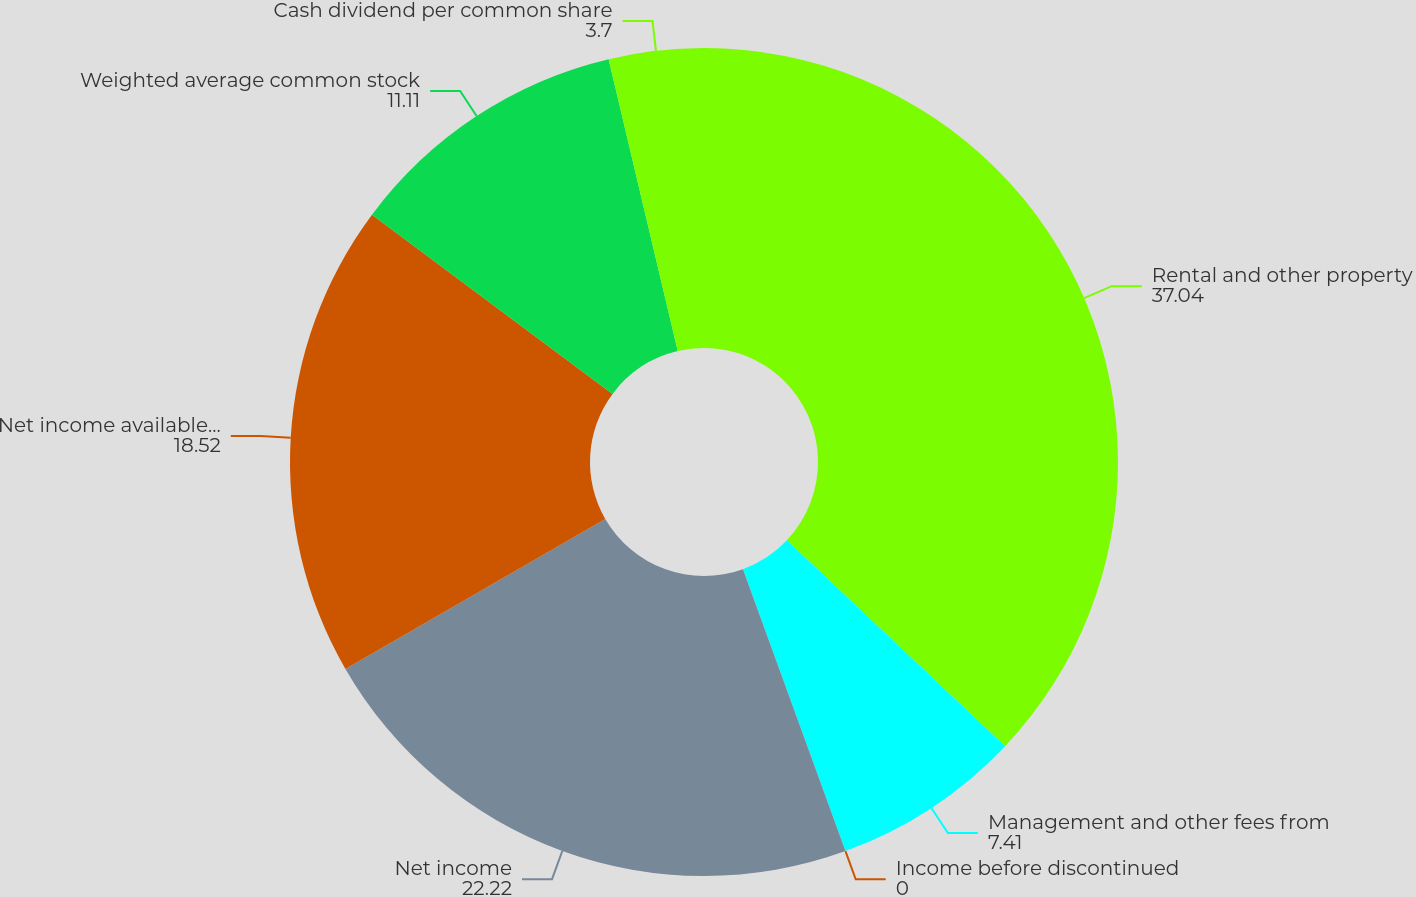Convert chart. <chart><loc_0><loc_0><loc_500><loc_500><pie_chart><fcel>Rental and other property<fcel>Management and other fees from<fcel>Income before discontinued<fcel>Net income<fcel>Net income available to common<fcel>Weighted average common stock<fcel>Cash dividend per common share<nl><fcel>37.04%<fcel>7.41%<fcel>0.0%<fcel>22.22%<fcel>18.52%<fcel>11.11%<fcel>3.7%<nl></chart> 